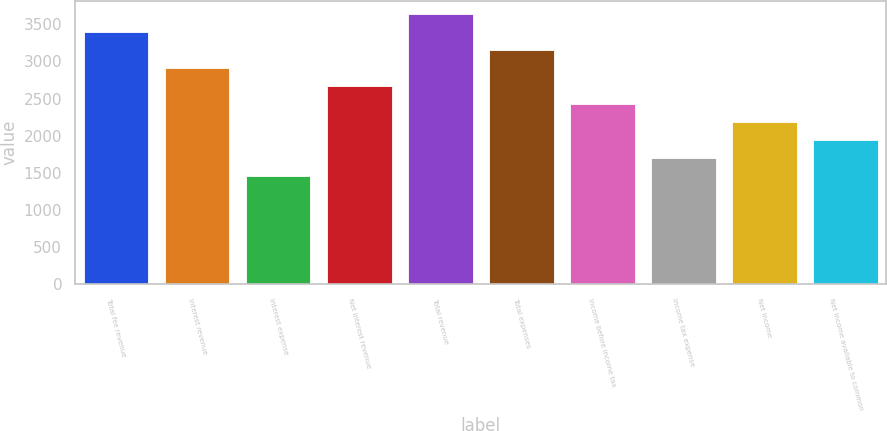Convert chart to OTSL. <chart><loc_0><loc_0><loc_500><loc_500><bar_chart><fcel>Total fee revenue<fcel>Interest revenue<fcel>Interest expense<fcel>Net interest revenue<fcel>Total revenue<fcel>Total expenses<fcel>Income before income tax<fcel>Income tax expense<fcel>Net income<fcel>Net income available to common<nl><fcel>3392.16<fcel>2907.6<fcel>1453.92<fcel>2665.32<fcel>3634.44<fcel>3149.88<fcel>2423.04<fcel>1696.2<fcel>2180.76<fcel>1938.48<nl></chart> 